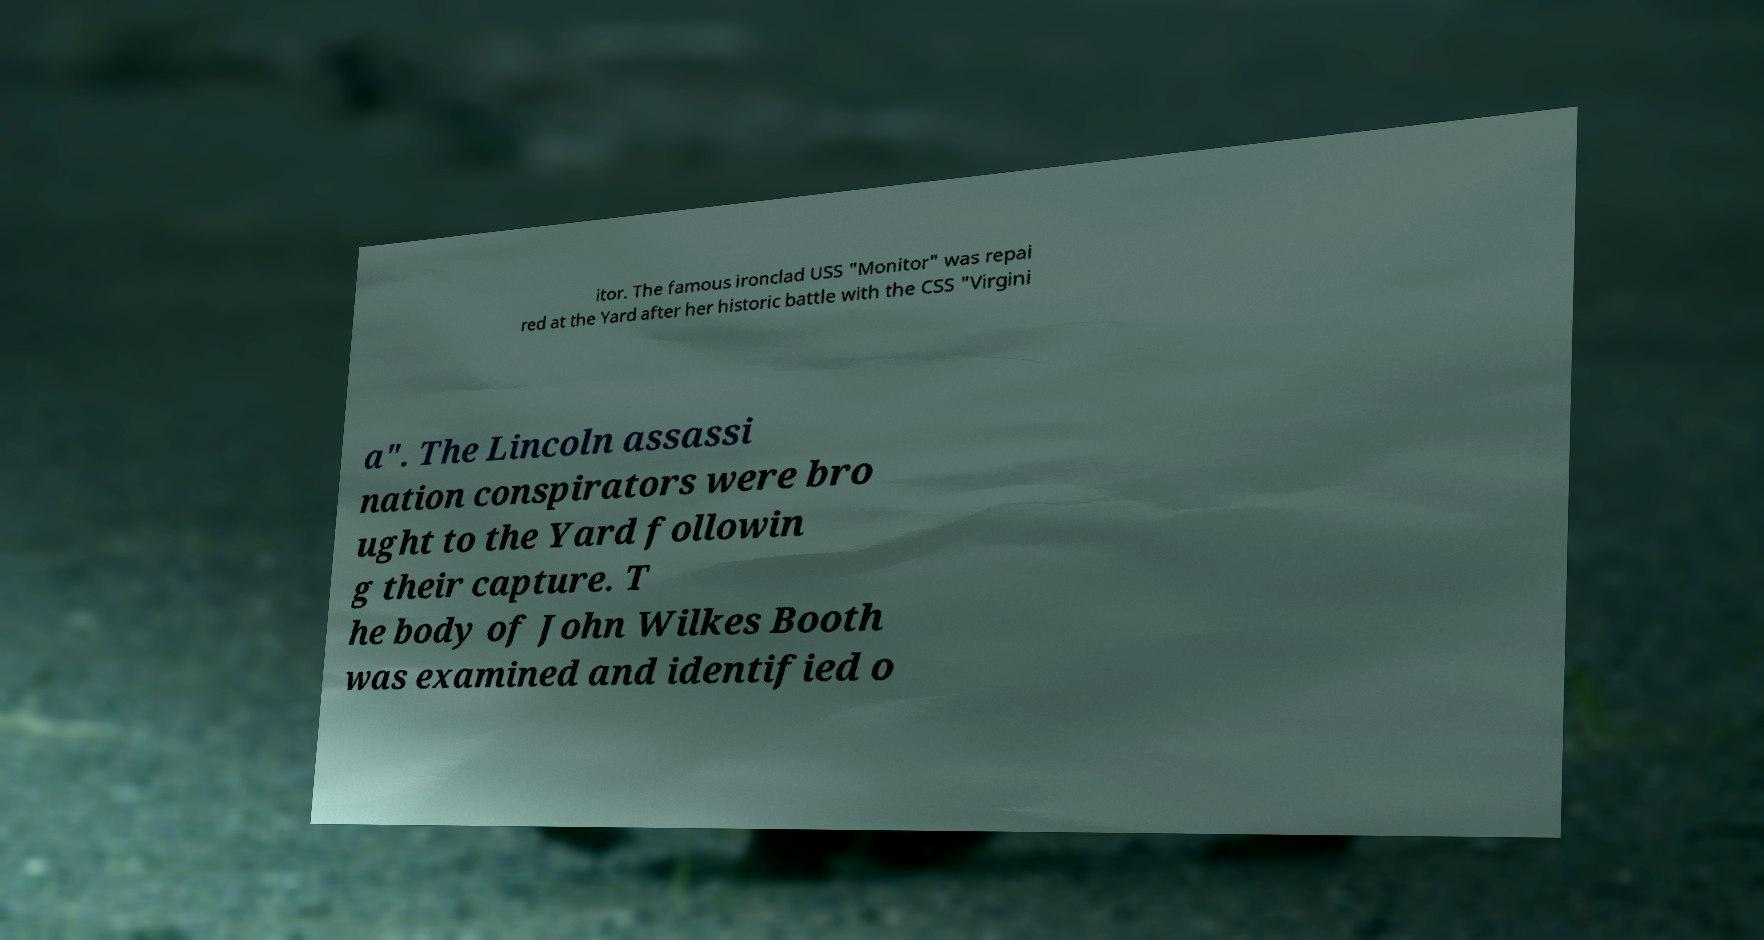I need the written content from this picture converted into text. Can you do that? itor. The famous ironclad USS "Monitor" was repai red at the Yard after her historic battle with the CSS "Virgini a". The Lincoln assassi nation conspirators were bro ught to the Yard followin g their capture. T he body of John Wilkes Booth was examined and identified o 